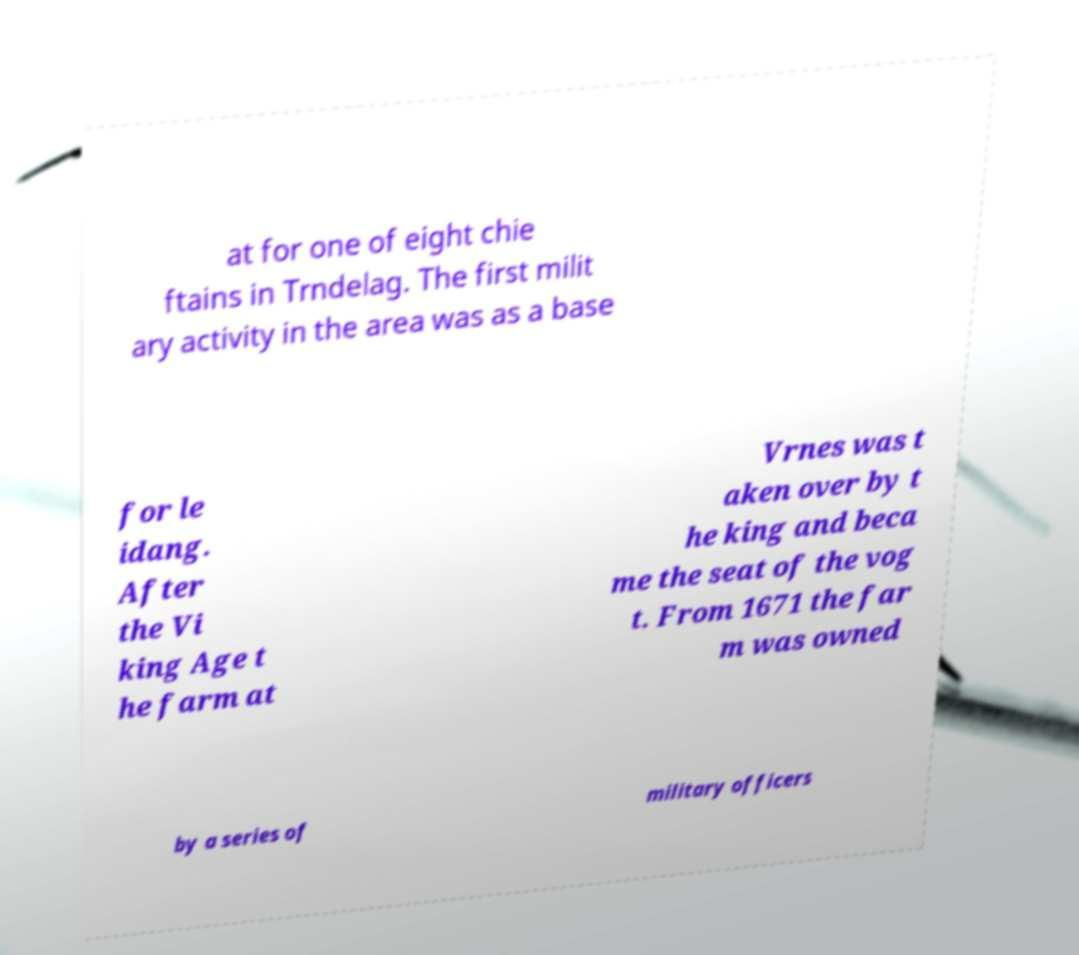Could you assist in decoding the text presented in this image and type it out clearly? at for one of eight chie ftains in Trndelag. The first milit ary activity in the area was as a base for le idang. After the Vi king Age t he farm at Vrnes was t aken over by t he king and beca me the seat of the vog t. From 1671 the far m was owned by a series of military officers 